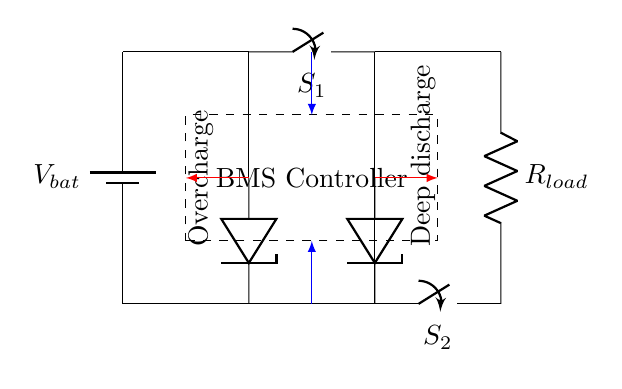what are the two types of protections in this circuit? The circuit diagram includes overcharge protection and deep discharge protection, which are represented by the two zener diodes labeled accordingly.
Answer: overcharge and deep discharge how many closing switches are present in the circuit? The circuit contains two closing switches, S1 and S2, which control the flow of current based on the overcharge and deep discharge conditions.
Answer: two what is the function of the BMS Controller in the diagram? The BMS Controller monitors the battery's status and manages the operation of both protection mechanisms, overcharge and deep discharge, ensuring the battery operates safely within specified limits.
Answer: monitors and manages protection which component limits the voltage during overcharging? The zener diode labeled "Overcharge" is responsible for limiting the voltage during overcharging by conducting current away from the battery when voltage exceeds a specified threshold.
Answer: zener diode what connections are made to the BMS Controller? The BMS Controller receives connections from both the overcharge protection section (via the zener diode) and the deep discharge protection section, allowing it to monitor battery conditions.
Answer: connections from overcharge and deep discharge at what point in the circuit does deep discharge protection occur? Deep discharge protection occurs at the zener diode located at the bottom of the circuit, which limits current flow when the battery voltage drops below a certain level to prevent damage.
Answer: zener diode in the deep discharge section how does the circuit indicate an overcharged condition? An overcharged condition is indicated when the voltage from the battery exceeds the set level, causing the zener diode in the overcharge protection section to conduct, effectively opening switch S1 and disconnecting the battery from the load.
Answer: by conducting through the zener diode 